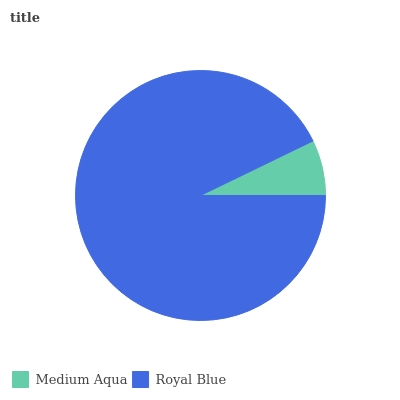Is Medium Aqua the minimum?
Answer yes or no. Yes. Is Royal Blue the maximum?
Answer yes or no. Yes. Is Royal Blue the minimum?
Answer yes or no. No. Is Royal Blue greater than Medium Aqua?
Answer yes or no. Yes. Is Medium Aqua less than Royal Blue?
Answer yes or no. Yes. Is Medium Aqua greater than Royal Blue?
Answer yes or no. No. Is Royal Blue less than Medium Aqua?
Answer yes or no. No. Is Royal Blue the high median?
Answer yes or no. Yes. Is Medium Aqua the low median?
Answer yes or no. Yes. Is Medium Aqua the high median?
Answer yes or no. No. Is Royal Blue the low median?
Answer yes or no. No. 